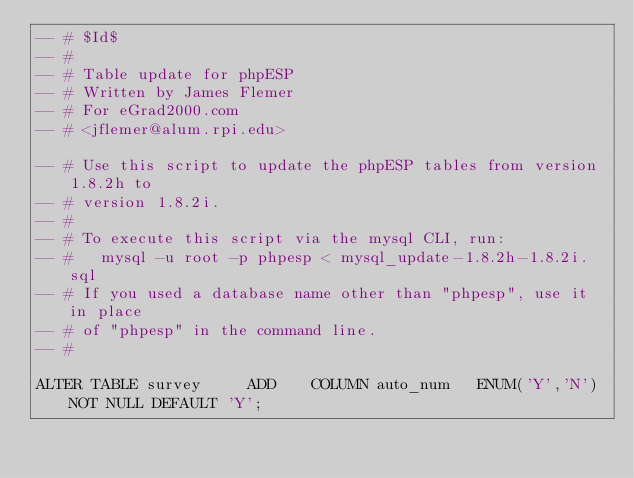<code> <loc_0><loc_0><loc_500><loc_500><_SQL_>-- # $Id$
-- #
-- # Table update for phpESP
-- # Written by James Flemer
-- # For eGrad2000.com
-- # <jflemer@alum.rpi.edu>

-- # Use this script to update the phpESP tables from version 1.8.2h to
-- # version 1.8.2i.
-- # 
-- # To execute this script via the mysql CLI, run:
-- #   mysql -u root -p phpesp < mysql_update-1.8.2h-1.8.2i.sql
-- # If you used a database name other than "phpesp", use it in place
-- # of "phpesp" in the command line.
-- #

ALTER TABLE survey     ADD    COLUMN auto_num   ENUM('Y','N') NOT NULL DEFAULT 'Y';
</code> 